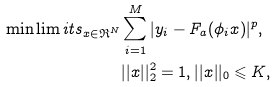<formula> <loc_0><loc_0><loc_500><loc_500>\min \lim i t s _ { x \in \mathfrak { R } ^ { N } } & \sum _ { i = 1 } ^ { M } | y _ { i } - F _ { a } ( \phi _ { i } x ) | ^ { p } , \\ & | | x | | _ { 2 } ^ { 2 } = 1 , | | x | | _ { 0 } \leqslant K ,</formula> 